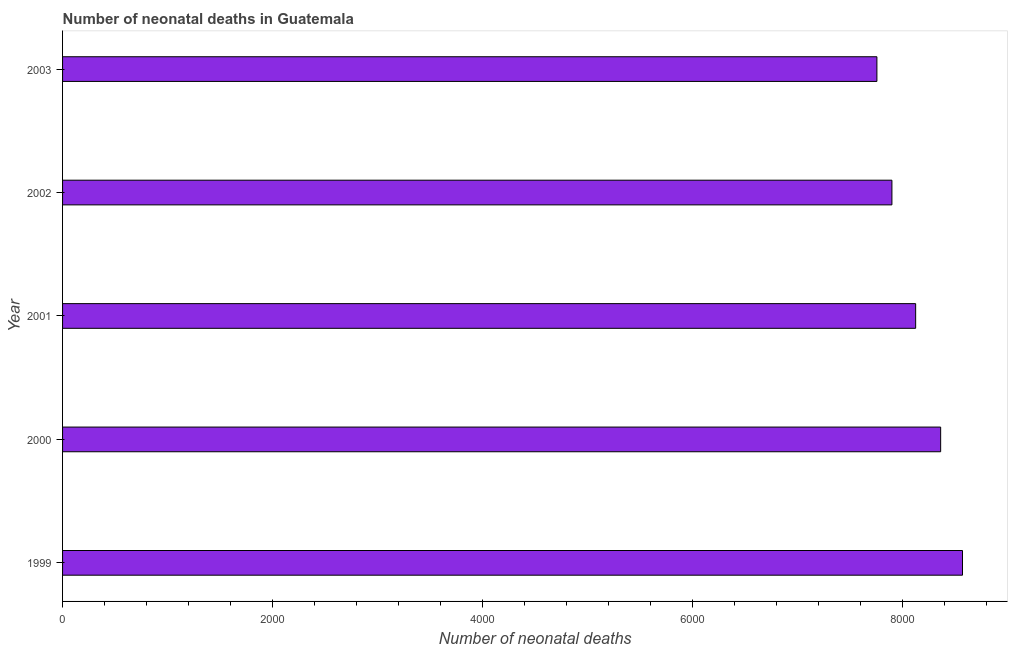Does the graph contain any zero values?
Make the answer very short. No. What is the title of the graph?
Provide a short and direct response. Number of neonatal deaths in Guatemala. What is the label or title of the X-axis?
Ensure brevity in your answer.  Number of neonatal deaths. What is the number of neonatal deaths in 2001?
Give a very brief answer. 8124. Across all years, what is the maximum number of neonatal deaths?
Make the answer very short. 8570. Across all years, what is the minimum number of neonatal deaths?
Provide a short and direct response. 7755. In which year was the number of neonatal deaths minimum?
Make the answer very short. 2003. What is the sum of the number of neonatal deaths?
Keep it short and to the point. 4.07e+04. What is the difference between the number of neonatal deaths in 2000 and 2002?
Provide a short and direct response. 464. What is the average number of neonatal deaths per year?
Offer a very short reply. 8141. What is the median number of neonatal deaths?
Your answer should be very brief. 8124. Do a majority of the years between 1999 and 2000 (inclusive) have number of neonatal deaths greater than 4400 ?
Offer a terse response. Yes. What is the ratio of the number of neonatal deaths in 1999 to that in 2000?
Keep it short and to the point. 1.02. Is the number of neonatal deaths in 2000 less than that in 2003?
Keep it short and to the point. No. What is the difference between the highest and the second highest number of neonatal deaths?
Ensure brevity in your answer.  208. What is the difference between the highest and the lowest number of neonatal deaths?
Your response must be concise. 815. In how many years, is the number of neonatal deaths greater than the average number of neonatal deaths taken over all years?
Give a very brief answer. 2. Are all the bars in the graph horizontal?
Ensure brevity in your answer.  Yes. What is the difference between two consecutive major ticks on the X-axis?
Offer a very short reply. 2000. What is the Number of neonatal deaths in 1999?
Make the answer very short. 8570. What is the Number of neonatal deaths of 2000?
Provide a short and direct response. 8362. What is the Number of neonatal deaths of 2001?
Your response must be concise. 8124. What is the Number of neonatal deaths of 2002?
Provide a short and direct response. 7898. What is the Number of neonatal deaths of 2003?
Ensure brevity in your answer.  7755. What is the difference between the Number of neonatal deaths in 1999 and 2000?
Give a very brief answer. 208. What is the difference between the Number of neonatal deaths in 1999 and 2001?
Ensure brevity in your answer.  446. What is the difference between the Number of neonatal deaths in 1999 and 2002?
Offer a very short reply. 672. What is the difference between the Number of neonatal deaths in 1999 and 2003?
Your answer should be very brief. 815. What is the difference between the Number of neonatal deaths in 2000 and 2001?
Ensure brevity in your answer.  238. What is the difference between the Number of neonatal deaths in 2000 and 2002?
Provide a succinct answer. 464. What is the difference between the Number of neonatal deaths in 2000 and 2003?
Make the answer very short. 607. What is the difference between the Number of neonatal deaths in 2001 and 2002?
Provide a short and direct response. 226. What is the difference between the Number of neonatal deaths in 2001 and 2003?
Make the answer very short. 369. What is the difference between the Number of neonatal deaths in 2002 and 2003?
Make the answer very short. 143. What is the ratio of the Number of neonatal deaths in 1999 to that in 2000?
Provide a succinct answer. 1.02. What is the ratio of the Number of neonatal deaths in 1999 to that in 2001?
Provide a succinct answer. 1.05. What is the ratio of the Number of neonatal deaths in 1999 to that in 2002?
Offer a very short reply. 1.08. What is the ratio of the Number of neonatal deaths in 1999 to that in 2003?
Provide a short and direct response. 1.1. What is the ratio of the Number of neonatal deaths in 2000 to that in 2002?
Offer a terse response. 1.06. What is the ratio of the Number of neonatal deaths in 2000 to that in 2003?
Offer a very short reply. 1.08. What is the ratio of the Number of neonatal deaths in 2001 to that in 2002?
Provide a succinct answer. 1.03. What is the ratio of the Number of neonatal deaths in 2001 to that in 2003?
Your answer should be very brief. 1.05. What is the ratio of the Number of neonatal deaths in 2002 to that in 2003?
Give a very brief answer. 1.02. 